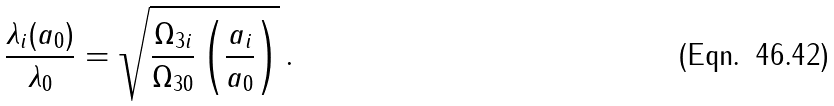<formula> <loc_0><loc_0><loc_500><loc_500>\frac { \lambda _ { i } ( a _ { 0 } ) } { \lambda _ { 0 } } = \sqrt { \frac { \Omega _ { 3 i } } { \Omega _ { 3 0 } } \left ( \frac { a _ { i } } { a _ { 0 } } \right ) } \, .</formula> 